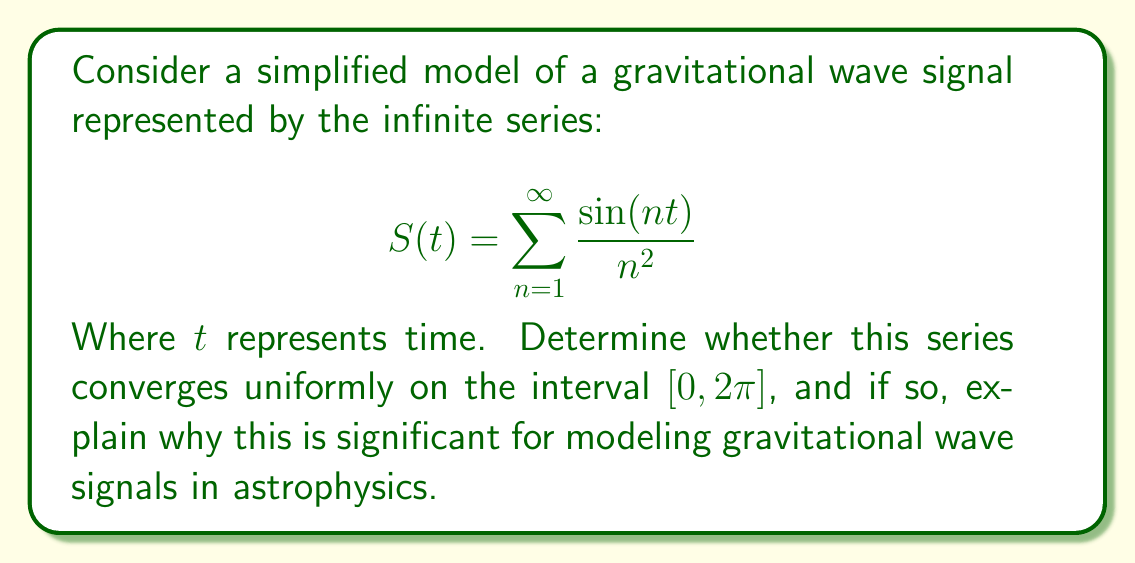Give your solution to this math problem. To analyze the uniform convergence of this series, we'll use the Weierstrass M-test.

1) First, let's find a bound for each term in the series:

   $$\left|\frac{\sin(nt)}{n^2}\right| \leq \frac{1}{n^2}$$

   This is because $|\sin(nt)| \leq 1$ for all $n$ and $t$.

2) Now, consider the series of these upper bounds:

   $$\sum_{n=1}^{\infty} \frac{1}{n^2}$$

3) This is a p-series with $p=2$. We know that p-series converge for $p > 1$, so this series converges.

4) Let's call the sum of this series $M$. We know that:

   $$M = \sum_{n=1}^{\infty} \frac{1}{n^2} = \frac{\pi^2}{6}$$

5) By the Weierstrass M-test, since we have found a convergent series of constants $M_n = \frac{1}{n^2}$ such that $|\frac{\sin(nt)}{n^2}| \leq M_n$ for all $n$ and all $t$ in $[0, 2\pi]$, the original series converges uniformly on $[0, 2\pi]$.

The uniform convergence of this series is significant for modeling gravitational wave signals in astrophysics for several reasons:

1) It ensures that the series representation of the signal is well-behaved and doesn't exhibit any sudden jumps or irregularities as more terms are added.

2) Uniform convergence allows us to differentiate or integrate the series term by term, which is crucial for analyzing properties of the gravitational wave signal such as its energy or frequency spectrum.

3) It guarantees that the series approximation is consistently accurate across the entire time interval, which is essential for reliable detection and analysis of gravitational waves.

4) The uniform convergence implies that a finite number of terms can approximate the signal to any desired accuracy, which is important for practical computations and simulations in gravitational wave research.
Answer: The series $S(t) = \sum_{n=1}^{\infty} \frac{\sin(nt)}{n^2}$ converges uniformly on the interval $[0, 2\pi]$. This uniform convergence is significant for modeling gravitational wave signals as it ensures consistent accuracy, allows term-by-term operations, and guarantees well-behaved approximations across the entire time interval. 